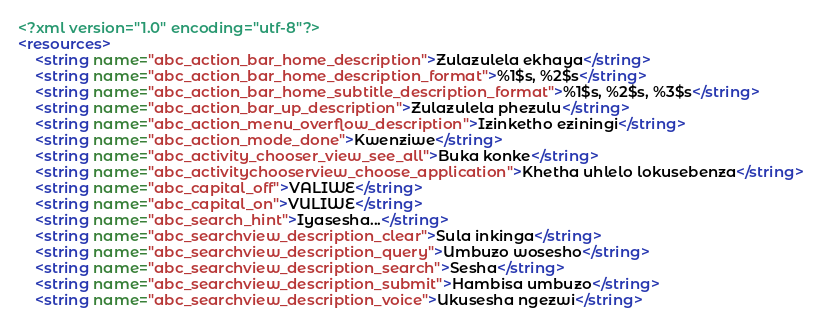<code> <loc_0><loc_0><loc_500><loc_500><_XML_><?xml version="1.0" encoding="utf-8"?>
<resources>
    <string name="abc_action_bar_home_description">Zulazulela ekhaya</string>
    <string name="abc_action_bar_home_description_format">%1$s, %2$s</string>
    <string name="abc_action_bar_home_subtitle_description_format">%1$s, %2$s, %3$s</string>
    <string name="abc_action_bar_up_description">Zulazulela phezulu</string>
    <string name="abc_action_menu_overflow_description">Izinketho eziningi</string>
    <string name="abc_action_mode_done">Kwenziwe</string>
    <string name="abc_activity_chooser_view_see_all">Buka konke</string>
    <string name="abc_activitychooserview_choose_application">Khetha uhlelo lokusebenza</string>
    <string name="abc_capital_off">VALIWE</string>
    <string name="abc_capital_on">VULIWE</string>
    <string name="abc_search_hint">Iyasesha...</string>
    <string name="abc_searchview_description_clear">Sula inkinga</string>
    <string name="abc_searchview_description_query">Umbuzo wosesho</string>
    <string name="abc_searchview_description_search">Sesha</string>
    <string name="abc_searchview_description_submit">Hambisa umbuzo</string>
    <string name="abc_searchview_description_voice">Ukusesha ngezwi</string></code> 